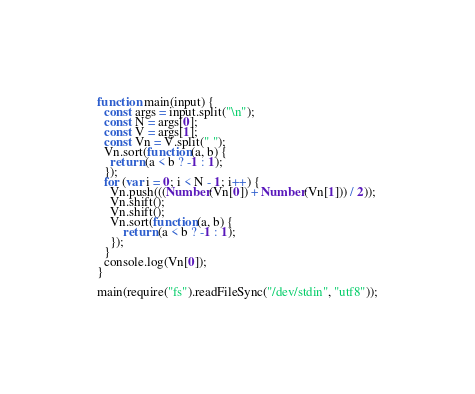<code> <loc_0><loc_0><loc_500><loc_500><_JavaScript_>function main(input) {
  const args = input.split("\n");
  const N = args[0];
  const V = args[1];
  const Vn = V.split(" ");
  Vn.sort(function(a, b) {
    return (a < b ? -1 : 1);
  });
  for (var i = 0; i < N - 1; i++) {
    Vn.push(((Number(Vn[0]) + Number(Vn[1])) / 2));
    Vn.shift();
    Vn.shift();
    Vn.sort(function(a, b) {
        return (a < b ? -1 : 1);
    });
  }
  console.log(Vn[0]);
}

main(require("fs").readFileSync("/dev/stdin", "utf8"));
</code> 